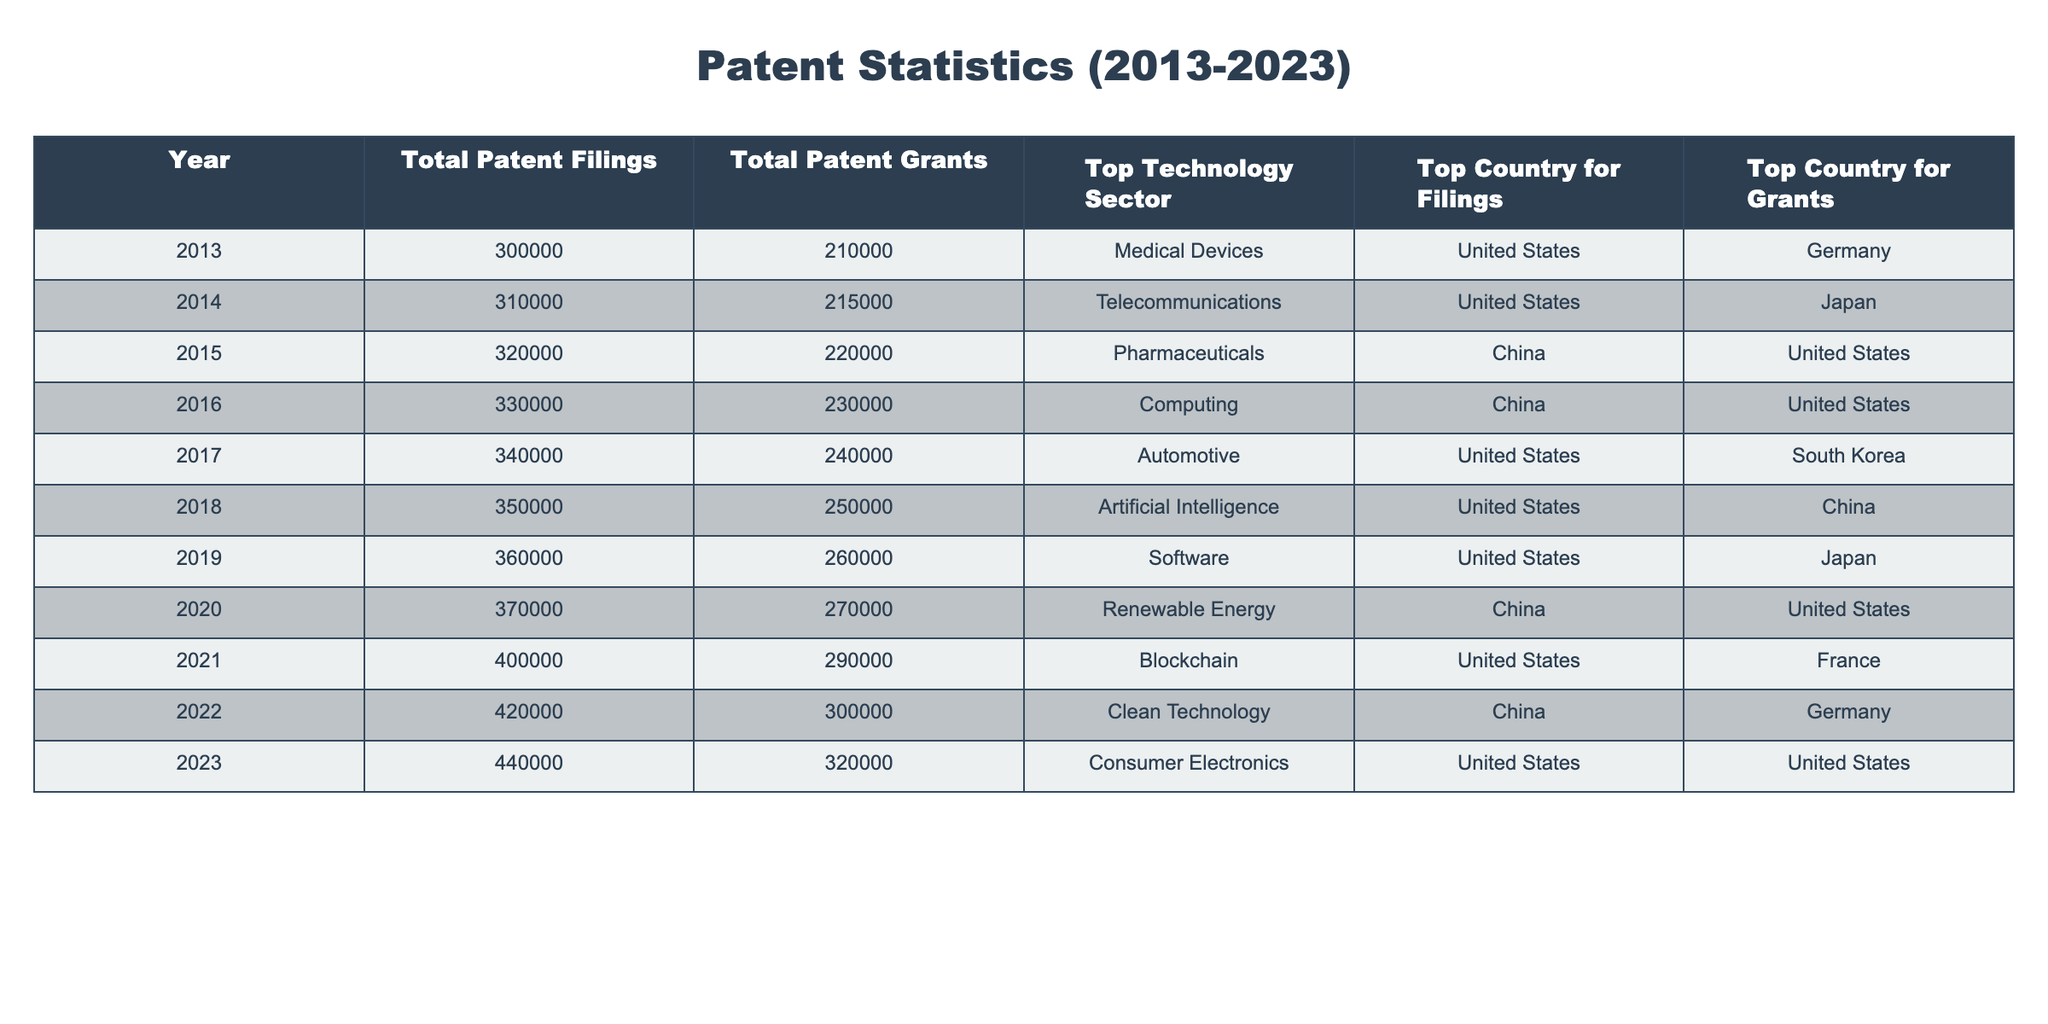What was the total number of patent filings in 2015? In the table, the data for the year 2015 indicates that the total patent filings were 320,000.
Answer: 320,000 Which technology sector had the highest number of patent grants in 2021? The table shows that in 2021, the top technology sector for patent grants was Blockchain, with a total of 290,000 grants.
Answer: Blockchain What is the difference between the total patent filings in 2023 and 2013? For 2023, the total patent filings were 440,000, and for 2013, it was 300,000. To find the difference: 440,000 - 300,000 = 140,000.
Answer: 140,000 Was there an increase in total patent grants from 2019 to 2020? In 2019, the total patent grants were 260,000, and in 2020, it rose to 270,000. Since 270,000 is greater than 260,000, it indicates an increase.
Answer: Yes Which country had the highest patent grants in 2022? According to the table, in 2022, the top country for patent grants was Germany.
Answer: Germany What is the average number of total patent filings from 2013 to 2020? The total patent filings from 2013 to 2020 are 300,000, 310,000, 320,000, 330,000, 340,000, 350,000, 360,000, and 370,000. The sum is 2,380,000, and there are 8 years, so the average is 2,380,000 / 8 = 297,500.
Answer: 297,500 In which year was the top technology sector for filings "Artificial Intelligence"? By examining the table, it shows that in 2018, the top technology sector for patent filings was Artificial Intelligence.
Answer: 2018 How many more patent grants were there in 2023 compared to 2022? The total patent grants in 2023 were 320,000, and in 2022, they were 300,000. Subtracting these values gives 320,000 - 300,000 = 20,000.
Answer: 20,000 Which country had the top number of patent filings for the majority of years? Reviewing the table, the United States consistently appears as the top country for patent filings for 2013, 2014, 2017, 2018, 2019, and 2021, thus it had the top number in most years.
Answer: United States 